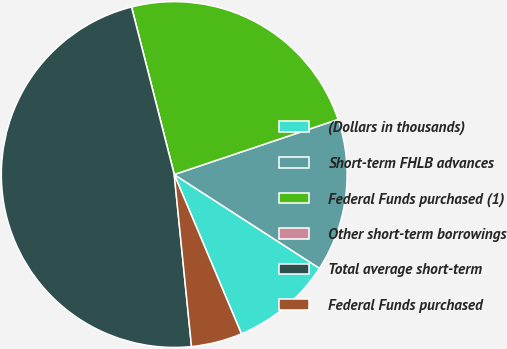Convert chart. <chart><loc_0><loc_0><loc_500><loc_500><pie_chart><fcel>(Dollars in thousands)<fcel>Short-term FHLB advances<fcel>Federal Funds purchased (1)<fcel>Other short-term borrowings<fcel>Total average short-term<fcel>Federal Funds purchased<nl><fcel>9.52%<fcel>14.29%<fcel>23.81%<fcel>0.0%<fcel>47.62%<fcel>4.76%<nl></chart> 